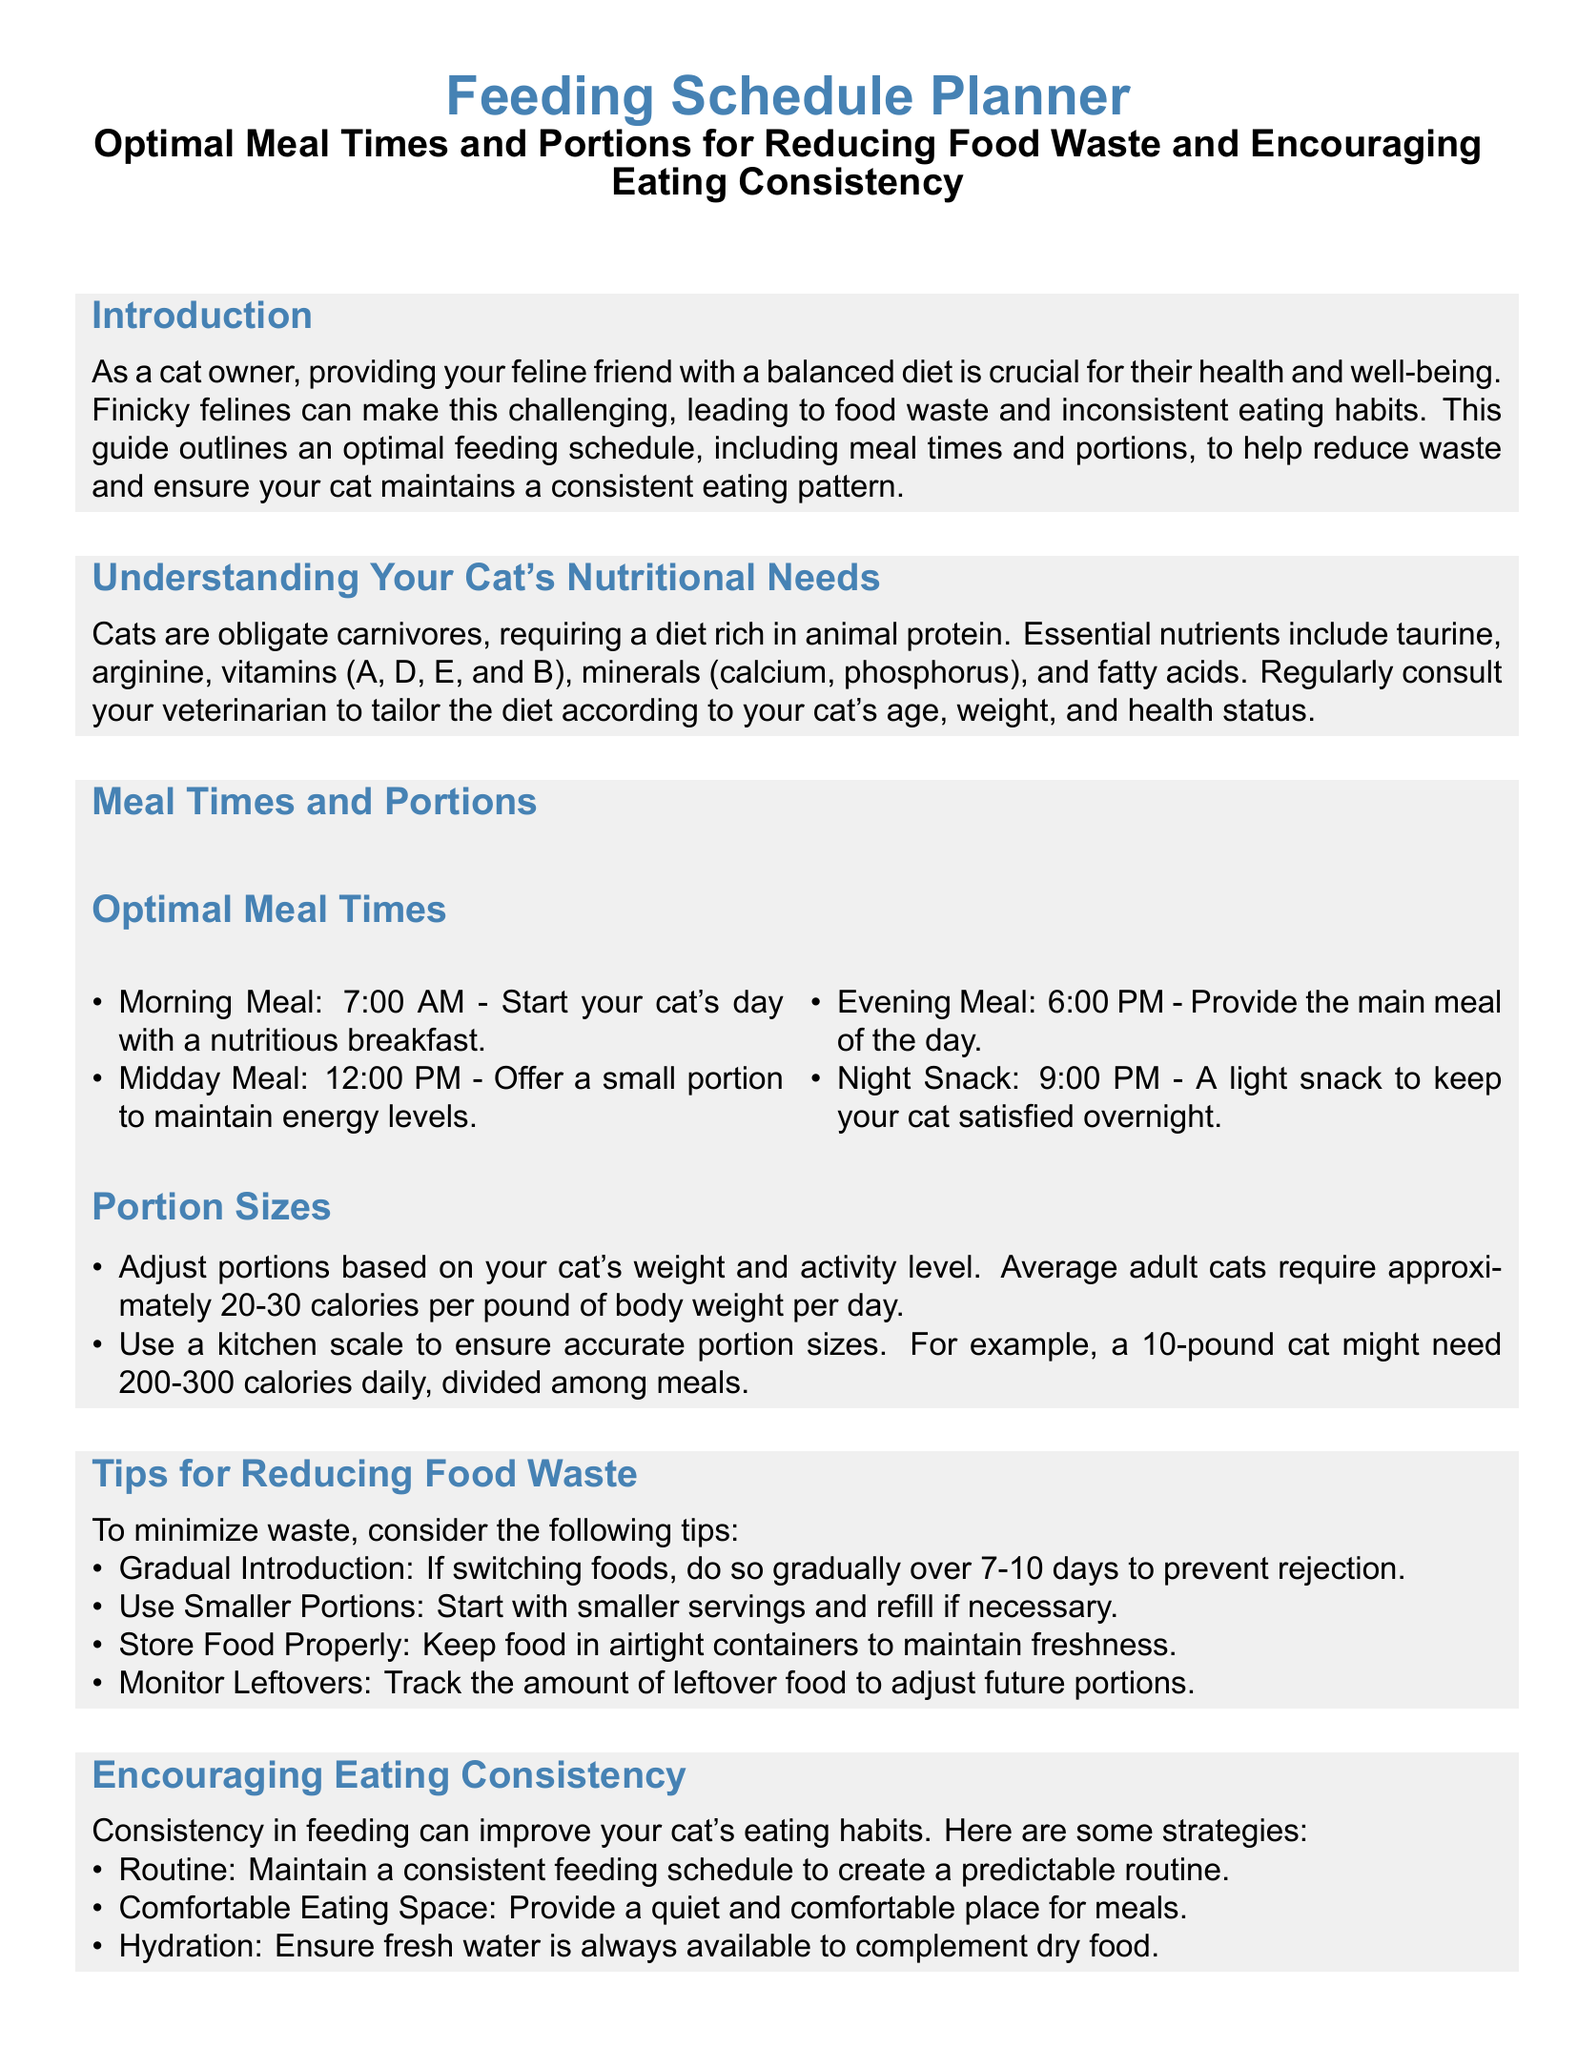What are the optimal meal times for a cat? The document lists four specific meal times for cats to maintain a consistent eating schedule: Morning Meal at 7:00 AM, Midday Meal at 12:00 PM, Evening Meal at 6:00 PM, and Night Snack at 9:00 PM.
Answer: 7:00 AM, 12:00 PM, 6:00 PM, 9:00 PM What is an essential nutrient for cats? The document highlights several essential nutrients required by cats, including taurine, arginine, vitamins (A, D, E, and B), minerals (calcium, phosphorus), and fatty acids. One example from this list is taurine.
Answer: Taurine What should be done to minimize food waste? The document provides various tips to reduce food waste, one of which is gradually introducing new food over 7-10 days to help prevent rejection by the cat.
Answer: Gradual Introduction How many calories does an average cat need per pound daily? The document states that average adult cats require approximately 20-30 calories per pound of body weight per day.
Answer: 20-30 calories What is an important factor to ensure eating consistency? Maintaining a consistent feeding schedule is identified in the document as a key factor in improving a cat's eating habits.
Answer: Routine What is the recommended Portion Size for a 10-pound cat? According to the document, a 10-pound cat might need 200-300 calories daily, divided among meals.
Answer: 200-300 calories What should be provided alongside dry food? The document emphasizes the need to ensure fresh water is always available to complement dry food, thus enhancing the cat's hydration.
Answer: Fresh water 